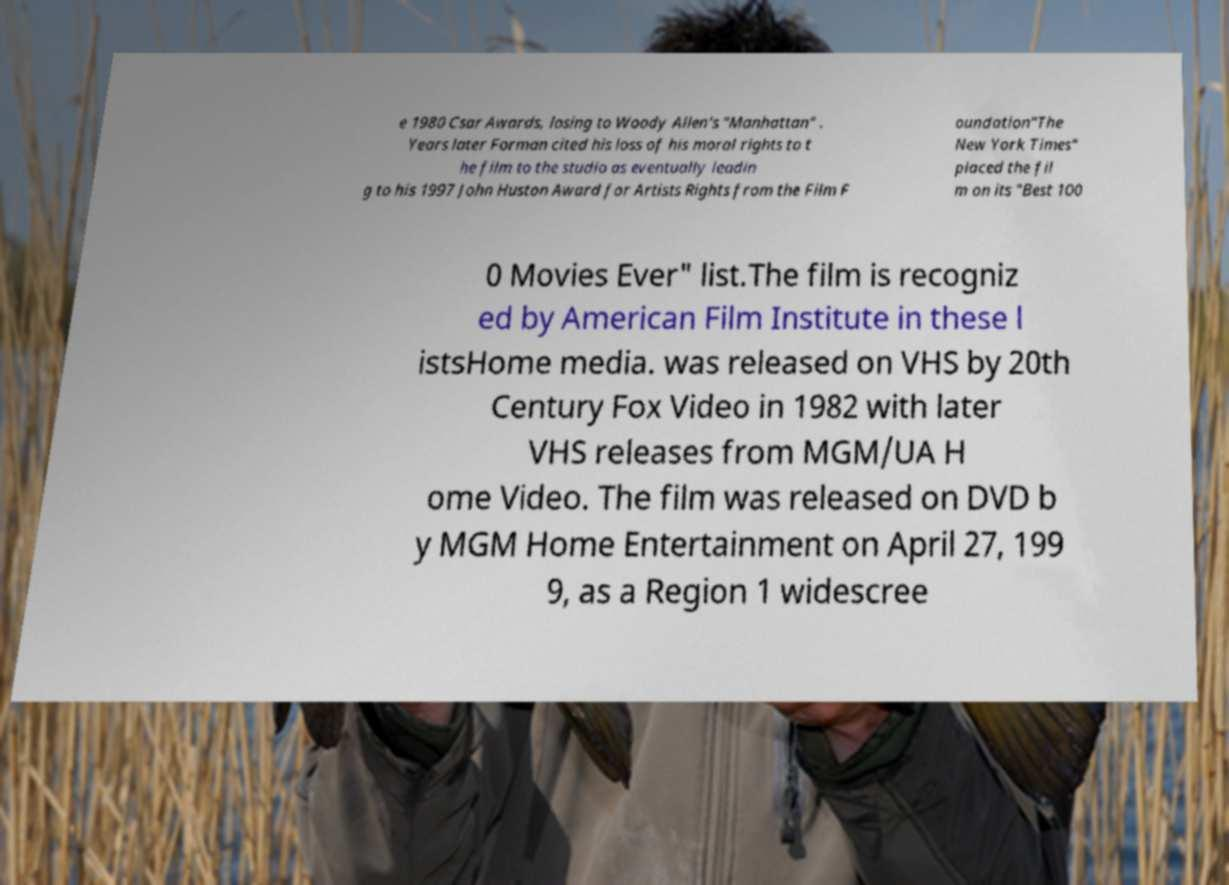I need the written content from this picture converted into text. Can you do that? e 1980 Csar Awards, losing to Woody Allen's "Manhattan" . Years later Forman cited his loss of his moral rights to t he film to the studio as eventually leadin g to his 1997 John Huston Award for Artists Rights from the Film F oundation"The New York Times" placed the fil m on its "Best 100 0 Movies Ever" list.The film is recogniz ed by American Film Institute in these l istsHome media. was released on VHS by 20th Century Fox Video in 1982 with later VHS releases from MGM/UA H ome Video. The film was released on DVD b y MGM Home Entertainment on April 27, 199 9, as a Region 1 widescree 